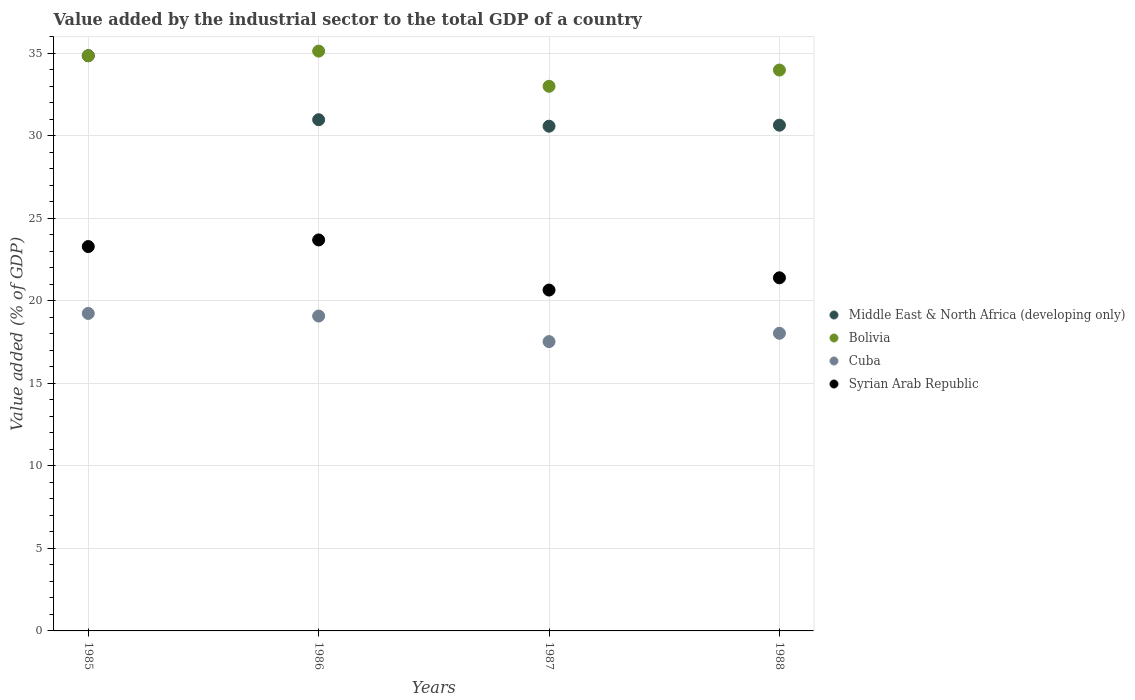How many different coloured dotlines are there?
Make the answer very short. 4. Is the number of dotlines equal to the number of legend labels?
Offer a terse response. Yes. What is the value added by the industrial sector to the total GDP in Cuba in 1987?
Your response must be concise. 17.53. Across all years, what is the maximum value added by the industrial sector to the total GDP in Bolivia?
Ensure brevity in your answer.  35.13. Across all years, what is the minimum value added by the industrial sector to the total GDP in Middle East & North Africa (developing only)?
Offer a very short reply. 30.58. What is the total value added by the industrial sector to the total GDP in Syrian Arab Republic in the graph?
Offer a terse response. 89.02. What is the difference between the value added by the industrial sector to the total GDP in Syrian Arab Republic in 1986 and that in 1988?
Your answer should be compact. 2.29. What is the difference between the value added by the industrial sector to the total GDP in Bolivia in 1985 and the value added by the industrial sector to the total GDP in Syrian Arab Republic in 1988?
Your answer should be compact. 13.45. What is the average value added by the industrial sector to the total GDP in Bolivia per year?
Offer a terse response. 34.24. In the year 1988, what is the difference between the value added by the industrial sector to the total GDP in Cuba and value added by the industrial sector to the total GDP in Bolivia?
Provide a succinct answer. -15.95. In how many years, is the value added by the industrial sector to the total GDP in Middle East & North Africa (developing only) greater than 33 %?
Offer a terse response. 1. What is the ratio of the value added by the industrial sector to the total GDP in Cuba in 1985 to that in 1988?
Ensure brevity in your answer.  1.07. What is the difference between the highest and the second highest value added by the industrial sector to the total GDP in Cuba?
Your answer should be very brief. 0.16. What is the difference between the highest and the lowest value added by the industrial sector to the total GDP in Middle East & North Africa (developing only)?
Offer a very short reply. 4.27. Is the value added by the industrial sector to the total GDP in Bolivia strictly less than the value added by the industrial sector to the total GDP in Middle East & North Africa (developing only) over the years?
Keep it short and to the point. No. How many years are there in the graph?
Ensure brevity in your answer.  4. What is the difference between two consecutive major ticks on the Y-axis?
Offer a very short reply. 5. Where does the legend appear in the graph?
Provide a succinct answer. Center right. What is the title of the graph?
Your response must be concise. Value added by the industrial sector to the total GDP of a country. What is the label or title of the Y-axis?
Offer a terse response. Value added (% of GDP). What is the Value added (% of GDP) in Middle East & North Africa (developing only) in 1985?
Provide a succinct answer. 34.85. What is the Value added (% of GDP) in Bolivia in 1985?
Offer a terse response. 34.85. What is the Value added (% of GDP) of Cuba in 1985?
Ensure brevity in your answer.  19.24. What is the Value added (% of GDP) in Syrian Arab Republic in 1985?
Offer a terse response. 23.29. What is the Value added (% of GDP) in Middle East & North Africa (developing only) in 1986?
Your answer should be very brief. 30.97. What is the Value added (% of GDP) of Bolivia in 1986?
Provide a short and direct response. 35.13. What is the Value added (% of GDP) of Cuba in 1986?
Your response must be concise. 19.08. What is the Value added (% of GDP) of Syrian Arab Republic in 1986?
Your answer should be very brief. 23.69. What is the Value added (% of GDP) of Middle East & North Africa (developing only) in 1987?
Offer a terse response. 30.58. What is the Value added (% of GDP) of Bolivia in 1987?
Offer a very short reply. 33. What is the Value added (% of GDP) of Cuba in 1987?
Provide a succinct answer. 17.53. What is the Value added (% of GDP) in Syrian Arab Republic in 1987?
Ensure brevity in your answer.  20.65. What is the Value added (% of GDP) in Middle East & North Africa (developing only) in 1988?
Your answer should be compact. 30.64. What is the Value added (% of GDP) of Bolivia in 1988?
Ensure brevity in your answer.  33.98. What is the Value added (% of GDP) in Cuba in 1988?
Offer a very short reply. 18.03. What is the Value added (% of GDP) in Syrian Arab Republic in 1988?
Offer a terse response. 21.39. Across all years, what is the maximum Value added (% of GDP) of Middle East & North Africa (developing only)?
Provide a short and direct response. 34.85. Across all years, what is the maximum Value added (% of GDP) in Bolivia?
Give a very brief answer. 35.13. Across all years, what is the maximum Value added (% of GDP) of Cuba?
Ensure brevity in your answer.  19.24. Across all years, what is the maximum Value added (% of GDP) in Syrian Arab Republic?
Your answer should be compact. 23.69. Across all years, what is the minimum Value added (% of GDP) in Middle East & North Africa (developing only)?
Keep it short and to the point. 30.58. Across all years, what is the minimum Value added (% of GDP) in Bolivia?
Your answer should be compact. 33. Across all years, what is the minimum Value added (% of GDP) in Cuba?
Provide a short and direct response. 17.53. Across all years, what is the minimum Value added (% of GDP) in Syrian Arab Republic?
Make the answer very short. 20.65. What is the total Value added (% of GDP) in Middle East & North Africa (developing only) in the graph?
Offer a very short reply. 127.05. What is the total Value added (% of GDP) in Bolivia in the graph?
Your answer should be compact. 136.96. What is the total Value added (% of GDP) in Cuba in the graph?
Make the answer very short. 73.88. What is the total Value added (% of GDP) in Syrian Arab Republic in the graph?
Offer a terse response. 89.02. What is the difference between the Value added (% of GDP) of Middle East & North Africa (developing only) in 1985 and that in 1986?
Keep it short and to the point. 3.88. What is the difference between the Value added (% of GDP) of Bolivia in 1985 and that in 1986?
Keep it short and to the point. -0.28. What is the difference between the Value added (% of GDP) in Cuba in 1985 and that in 1986?
Ensure brevity in your answer.  0.16. What is the difference between the Value added (% of GDP) of Syrian Arab Republic in 1985 and that in 1986?
Your response must be concise. -0.4. What is the difference between the Value added (% of GDP) in Middle East & North Africa (developing only) in 1985 and that in 1987?
Make the answer very short. 4.27. What is the difference between the Value added (% of GDP) in Bolivia in 1985 and that in 1987?
Make the answer very short. 1.85. What is the difference between the Value added (% of GDP) in Cuba in 1985 and that in 1987?
Ensure brevity in your answer.  1.71. What is the difference between the Value added (% of GDP) in Syrian Arab Republic in 1985 and that in 1987?
Keep it short and to the point. 2.64. What is the difference between the Value added (% of GDP) in Middle East & North Africa (developing only) in 1985 and that in 1988?
Provide a short and direct response. 4.21. What is the difference between the Value added (% of GDP) in Bolivia in 1985 and that in 1988?
Offer a very short reply. 0.87. What is the difference between the Value added (% of GDP) of Cuba in 1985 and that in 1988?
Ensure brevity in your answer.  1.2. What is the difference between the Value added (% of GDP) of Syrian Arab Republic in 1985 and that in 1988?
Offer a very short reply. 1.89. What is the difference between the Value added (% of GDP) of Middle East & North Africa (developing only) in 1986 and that in 1987?
Ensure brevity in your answer.  0.39. What is the difference between the Value added (% of GDP) of Bolivia in 1986 and that in 1987?
Make the answer very short. 2.13. What is the difference between the Value added (% of GDP) in Cuba in 1986 and that in 1987?
Ensure brevity in your answer.  1.55. What is the difference between the Value added (% of GDP) of Syrian Arab Republic in 1986 and that in 1987?
Give a very brief answer. 3.04. What is the difference between the Value added (% of GDP) in Middle East & North Africa (developing only) in 1986 and that in 1988?
Your answer should be compact. 0.33. What is the difference between the Value added (% of GDP) in Bolivia in 1986 and that in 1988?
Give a very brief answer. 1.15. What is the difference between the Value added (% of GDP) of Cuba in 1986 and that in 1988?
Give a very brief answer. 1.04. What is the difference between the Value added (% of GDP) of Syrian Arab Republic in 1986 and that in 1988?
Provide a short and direct response. 2.29. What is the difference between the Value added (% of GDP) in Middle East & North Africa (developing only) in 1987 and that in 1988?
Your response must be concise. -0.06. What is the difference between the Value added (% of GDP) of Bolivia in 1987 and that in 1988?
Ensure brevity in your answer.  -0.98. What is the difference between the Value added (% of GDP) of Cuba in 1987 and that in 1988?
Provide a succinct answer. -0.5. What is the difference between the Value added (% of GDP) of Syrian Arab Republic in 1987 and that in 1988?
Provide a succinct answer. -0.74. What is the difference between the Value added (% of GDP) of Middle East & North Africa (developing only) in 1985 and the Value added (% of GDP) of Bolivia in 1986?
Offer a very short reply. -0.28. What is the difference between the Value added (% of GDP) in Middle East & North Africa (developing only) in 1985 and the Value added (% of GDP) in Cuba in 1986?
Your answer should be compact. 15.78. What is the difference between the Value added (% of GDP) of Middle East & North Africa (developing only) in 1985 and the Value added (% of GDP) of Syrian Arab Republic in 1986?
Ensure brevity in your answer.  11.16. What is the difference between the Value added (% of GDP) of Bolivia in 1985 and the Value added (% of GDP) of Cuba in 1986?
Offer a terse response. 15.77. What is the difference between the Value added (% of GDP) in Bolivia in 1985 and the Value added (% of GDP) in Syrian Arab Republic in 1986?
Give a very brief answer. 11.16. What is the difference between the Value added (% of GDP) in Cuba in 1985 and the Value added (% of GDP) in Syrian Arab Republic in 1986?
Provide a succinct answer. -4.45. What is the difference between the Value added (% of GDP) of Middle East & North Africa (developing only) in 1985 and the Value added (% of GDP) of Bolivia in 1987?
Keep it short and to the point. 1.85. What is the difference between the Value added (% of GDP) of Middle East & North Africa (developing only) in 1985 and the Value added (% of GDP) of Cuba in 1987?
Make the answer very short. 17.32. What is the difference between the Value added (% of GDP) in Middle East & North Africa (developing only) in 1985 and the Value added (% of GDP) in Syrian Arab Republic in 1987?
Keep it short and to the point. 14.2. What is the difference between the Value added (% of GDP) of Bolivia in 1985 and the Value added (% of GDP) of Cuba in 1987?
Your answer should be very brief. 17.32. What is the difference between the Value added (% of GDP) of Bolivia in 1985 and the Value added (% of GDP) of Syrian Arab Republic in 1987?
Provide a short and direct response. 14.2. What is the difference between the Value added (% of GDP) in Cuba in 1985 and the Value added (% of GDP) in Syrian Arab Republic in 1987?
Provide a short and direct response. -1.42. What is the difference between the Value added (% of GDP) of Middle East & North Africa (developing only) in 1985 and the Value added (% of GDP) of Bolivia in 1988?
Offer a very short reply. 0.87. What is the difference between the Value added (% of GDP) of Middle East & North Africa (developing only) in 1985 and the Value added (% of GDP) of Cuba in 1988?
Offer a very short reply. 16.82. What is the difference between the Value added (% of GDP) in Middle East & North Africa (developing only) in 1985 and the Value added (% of GDP) in Syrian Arab Republic in 1988?
Your answer should be compact. 13.46. What is the difference between the Value added (% of GDP) in Bolivia in 1985 and the Value added (% of GDP) in Cuba in 1988?
Give a very brief answer. 16.81. What is the difference between the Value added (% of GDP) of Bolivia in 1985 and the Value added (% of GDP) of Syrian Arab Republic in 1988?
Provide a succinct answer. 13.45. What is the difference between the Value added (% of GDP) in Cuba in 1985 and the Value added (% of GDP) in Syrian Arab Republic in 1988?
Offer a terse response. -2.16. What is the difference between the Value added (% of GDP) of Middle East & North Africa (developing only) in 1986 and the Value added (% of GDP) of Bolivia in 1987?
Provide a succinct answer. -2.02. What is the difference between the Value added (% of GDP) of Middle East & North Africa (developing only) in 1986 and the Value added (% of GDP) of Cuba in 1987?
Provide a short and direct response. 13.44. What is the difference between the Value added (% of GDP) in Middle East & North Africa (developing only) in 1986 and the Value added (% of GDP) in Syrian Arab Republic in 1987?
Provide a short and direct response. 10.32. What is the difference between the Value added (% of GDP) in Bolivia in 1986 and the Value added (% of GDP) in Cuba in 1987?
Give a very brief answer. 17.6. What is the difference between the Value added (% of GDP) of Bolivia in 1986 and the Value added (% of GDP) of Syrian Arab Republic in 1987?
Provide a short and direct response. 14.48. What is the difference between the Value added (% of GDP) of Cuba in 1986 and the Value added (% of GDP) of Syrian Arab Republic in 1987?
Ensure brevity in your answer.  -1.58. What is the difference between the Value added (% of GDP) of Middle East & North Africa (developing only) in 1986 and the Value added (% of GDP) of Bolivia in 1988?
Make the answer very short. -3.01. What is the difference between the Value added (% of GDP) in Middle East & North Africa (developing only) in 1986 and the Value added (% of GDP) in Cuba in 1988?
Make the answer very short. 12.94. What is the difference between the Value added (% of GDP) in Middle East & North Africa (developing only) in 1986 and the Value added (% of GDP) in Syrian Arab Republic in 1988?
Ensure brevity in your answer.  9.58. What is the difference between the Value added (% of GDP) in Bolivia in 1986 and the Value added (% of GDP) in Cuba in 1988?
Your response must be concise. 17.1. What is the difference between the Value added (% of GDP) of Bolivia in 1986 and the Value added (% of GDP) of Syrian Arab Republic in 1988?
Ensure brevity in your answer.  13.74. What is the difference between the Value added (% of GDP) of Cuba in 1986 and the Value added (% of GDP) of Syrian Arab Republic in 1988?
Provide a short and direct response. -2.32. What is the difference between the Value added (% of GDP) in Middle East & North Africa (developing only) in 1987 and the Value added (% of GDP) in Bolivia in 1988?
Make the answer very short. -3.4. What is the difference between the Value added (% of GDP) of Middle East & North Africa (developing only) in 1987 and the Value added (% of GDP) of Cuba in 1988?
Make the answer very short. 12.55. What is the difference between the Value added (% of GDP) of Middle East & North Africa (developing only) in 1987 and the Value added (% of GDP) of Syrian Arab Republic in 1988?
Ensure brevity in your answer.  9.19. What is the difference between the Value added (% of GDP) of Bolivia in 1987 and the Value added (% of GDP) of Cuba in 1988?
Offer a very short reply. 14.96. What is the difference between the Value added (% of GDP) of Bolivia in 1987 and the Value added (% of GDP) of Syrian Arab Republic in 1988?
Your response must be concise. 11.6. What is the difference between the Value added (% of GDP) in Cuba in 1987 and the Value added (% of GDP) in Syrian Arab Republic in 1988?
Your answer should be very brief. -3.87. What is the average Value added (% of GDP) in Middle East & North Africa (developing only) per year?
Ensure brevity in your answer.  31.76. What is the average Value added (% of GDP) in Bolivia per year?
Make the answer very short. 34.24. What is the average Value added (% of GDP) in Cuba per year?
Provide a short and direct response. 18.47. What is the average Value added (% of GDP) of Syrian Arab Republic per year?
Your answer should be very brief. 22.26. In the year 1985, what is the difference between the Value added (% of GDP) in Middle East & North Africa (developing only) and Value added (% of GDP) in Bolivia?
Offer a terse response. 0. In the year 1985, what is the difference between the Value added (% of GDP) in Middle East & North Africa (developing only) and Value added (% of GDP) in Cuba?
Offer a terse response. 15.62. In the year 1985, what is the difference between the Value added (% of GDP) in Middle East & North Africa (developing only) and Value added (% of GDP) in Syrian Arab Republic?
Keep it short and to the point. 11.56. In the year 1985, what is the difference between the Value added (% of GDP) of Bolivia and Value added (% of GDP) of Cuba?
Offer a terse response. 15.61. In the year 1985, what is the difference between the Value added (% of GDP) in Bolivia and Value added (% of GDP) in Syrian Arab Republic?
Your answer should be compact. 11.56. In the year 1985, what is the difference between the Value added (% of GDP) of Cuba and Value added (% of GDP) of Syrian Arab Republic?
Your answer should be very brief. -4.05. In the year 1986, what is the difference between the Value added (% of GDP) of Middle East & North Africa (developing only) and Value added (% of GDP) of Bolivia?
Ensure brevity in your answer.  -4.16. In the year 1986, what is the difference between the Value added (% of GDP) of Middle East & North Africa (developing only) and Value added (% of GDP) of Cuba?
Offer a very short reply. 11.9. In the year 1986, what is the difference between the Value added (% of GDP) of Middle East & North Africa (developing only) and Value added (% of GDP) of Syrian Arab Republic?
Your answer should be very brief. 7.28. In the year 1986, what is the difference between the Value added (% of GDP) in Bolivia and Value added (% of GDP) in Cuba?
Your answer should be compact. 16.05. In the year 1986, what is the difference between the Value added (% of GDP) in Bolivia and Value added (% of GDP) in Syrian Arab Republic?
Your response must be concise. 11.44. In the year 1986, what is the difference between the Value added (% of GDP) in Cuba and Value added (% of GDP) in Syrian Arab Republic?
Keep it short and to the point. -4.61. In the year 1987, what is the difference between the Value added (% of GDP) in Middle East & North Africa (developing only) and Value added (% of GDP) in Bolivia?
Give a very brief answer. -2.42. In the year 1987, what is the difference between the Value added (% of GDP) of Middle East & North Africa (developing only) and Value added (% of GDP) of Cuba?
Your response must be concise. 13.05. In the year 1987, what is the difference between the Value added (% of GDP) in Middle East & North Africa (developing only) and Value added (% of GDP) in Syrian Arab Republic?
Offer a very short reply. 9.93. In the year 1987, what is the difference between the Value added (% of GDP) of Bolivia and Value added (% of GDP) of Cuba?
Offer a terse response. 15.47. In the year 1987, what is the difference between the Value added (% of GDP) of Bolivia and Value added (% of GDP) of Syrian Arab Republic?
Offer a very short reply. 12.35. In the year 1987, what is the difference between the Value added (% of GDP) of Cuba and Value added (% of GDP) of Syrian Arab Republic?
Offer a terse response. -3.12. In the year 1988, what is the difference between the Value added (% of GDP) of Middle East & North Africa (developing only) and Value added (% of GDP) of Bolivia?
Give a very brief answer. -3.34. In the year 1988, what is the difference between the Value added (% of GDP) in Middle East & North Africa (developing only) and Value added (% of GDP) in Cuba?
Make the answer very short. 12.61. In the year 1988, what is the difference between the Value added (% of GDP) in Middle East & North Africa (developing only) and Value added (% of GDP) in Syrian Arab Republic?
Make the answer very short. 9.25. In the year 1988, what is the difference between the Value added (% of GDP) in Bolivia and Value added (% of GDP) in Cuba?
Ensure brevity in your answer.  15.95. In the year 1988, what is the difference between the Value added (% of GDP) of Bolivia and Value added (% of GDP) of Syrian Arab Republic?
Provide a succinct answer. 12.59. In the year 1988, what is the difference between the Value added (% of GDP) in Cuba and Value added (% of GDP) in Syrian Arab Republic?
Give a very brief answer. -3.36. What is the ratio of the Value added (% of GDP) of Middle East & North Africa (developing only) in 1985 to that in 1986?
Provide a short and direct response. 1.13. What is the ratio of the Value added (% of GDP) in Bolivia in 1985 to that in 1986?
Your answer should be very brief. 0.99. What is the ratio of the Value added (% of GDP) in Cuba in 1985 to that in 1986?
Provide a succinct answer. 1.01. What is the ratio of the Value added (% of GDP) of Syrian Arab Republic in 1985 to that in 1986?
Your answer should be compact. 0.98. What is the ratio of the Value added (% of GDP) in Middle East & North Africa (developing only) in 1985 to that in 1987?
Give a very brief answer. 1.14. What is the ratio of the Value added (% of GDP) of Bolivia in 1985 to that in 1987?
Keep it short and to the point. 1.06. What is the ratio of the Value added (% of GDP) in Cuba in 1985 to that in 1987?
Ensure brevity in your answer.  1.1. What is the ratio of the Value added (% of GDP) of Syrian Arab Republic in 1985 to that in 1987?
Ensure brevity in your answer.  1.13. What is the ratio of the Value added (% of GDP) in Middle East & North Africa (developing only) in 1985 to that in 1988?
Make the answer very short. 1.14. What is the ratio of the Value added (% of GDP) of Bolivia in 1985 to that in 1988?
Provide a succinct answer. 1.03. What is the ratio of the Value added (% of GDP) of Cuba in 1985 to that in 1988?
Make the answer very short. 1.07. What is the ratio of the Value added (% of GDP) of Syrian Arab Republic in 1985 to that in 1988?
Your answer should be compact. 1.09. What is the ratio of the Value added (% of GDP) in Middle East & North Africa (developing only) in 1986 to that in 1987?
Provide a short and direct response. 1.01. What is the ratio of the Value added (% of GDP) of Bolivia in 1986 to that in 1987?
Provide a short and direct response. 1.06. What is the ratio of the Value added (% of GDP) in Cuba in 1986 to that in 1987?
Your answer should be very brief. 1.09. What is the ratio of the Value added (% of GDP) of Syrian Arab Republic in 1986 to that in 1987?
Make the answer very short. 1.15. What is the ratio of the Value added (% of GDP) of Middle East & North Africa (developing only) in 1986 to that in 1988?
Keep it short and to the point. 1.01. What is the ratio of the Value added (% of GDP) in Bolivia in 1986 to that in 1988?
Offer a terse response. 1.03. What is the ratio of the Value added (% of GDP) of Cuba in 1986 to that in 1988?
Your response must be concise. 1.06. What is the ratio of the Value added (% of GDP) of Syrian Arab Republic in 1986 to that in 1988?
Offer a very short reply. 1.11. What is the ratio of the Value added (% of GDP) of Cuba in 1987 to that in 1988?
Offer a very short reply. 0.97. What is the ratio of the Value added (% of GDP) in Syrian Arab Republic in 1987 to that in 1988?
Your response must be concise. 0.97. What is the difference between the highest and the second highest Value added (% of GDP) of Middle East & North Africa (developing only)?
Provide a succinct answer. 3.88. What is the difference between the highest and the second highest Value added (% of GDP) in Bolivia?
Give a very brief answer. 0.28. What is the difference between the highest and the second highest Value added (% of GDP) in Cuba?
Provide a short and direct response. 0.16. What is the difference between the highest and the second highest Value added (% of GDP) of Syrian Arab Republic?
Ensure brevity in your answer.  0.4. What is the difference between the highest and the lowest Value added (% of GDP) of Middle East & North Africa (developing only)?
Make the answer very short. 4.27. What is the difference between the highest and the lowest Value added (% of GDP) in Bolivia?
Your response must be concise. 2.13. What is the difference between the highest and the lowest Value added (% of GDP) in Cuba?
Keep it short and to the point. 1.71. What is the difference between the highest and the lowest Value added (% of GDP) in Syrian Arab Republic?
Offer a terse response. 3.04. 